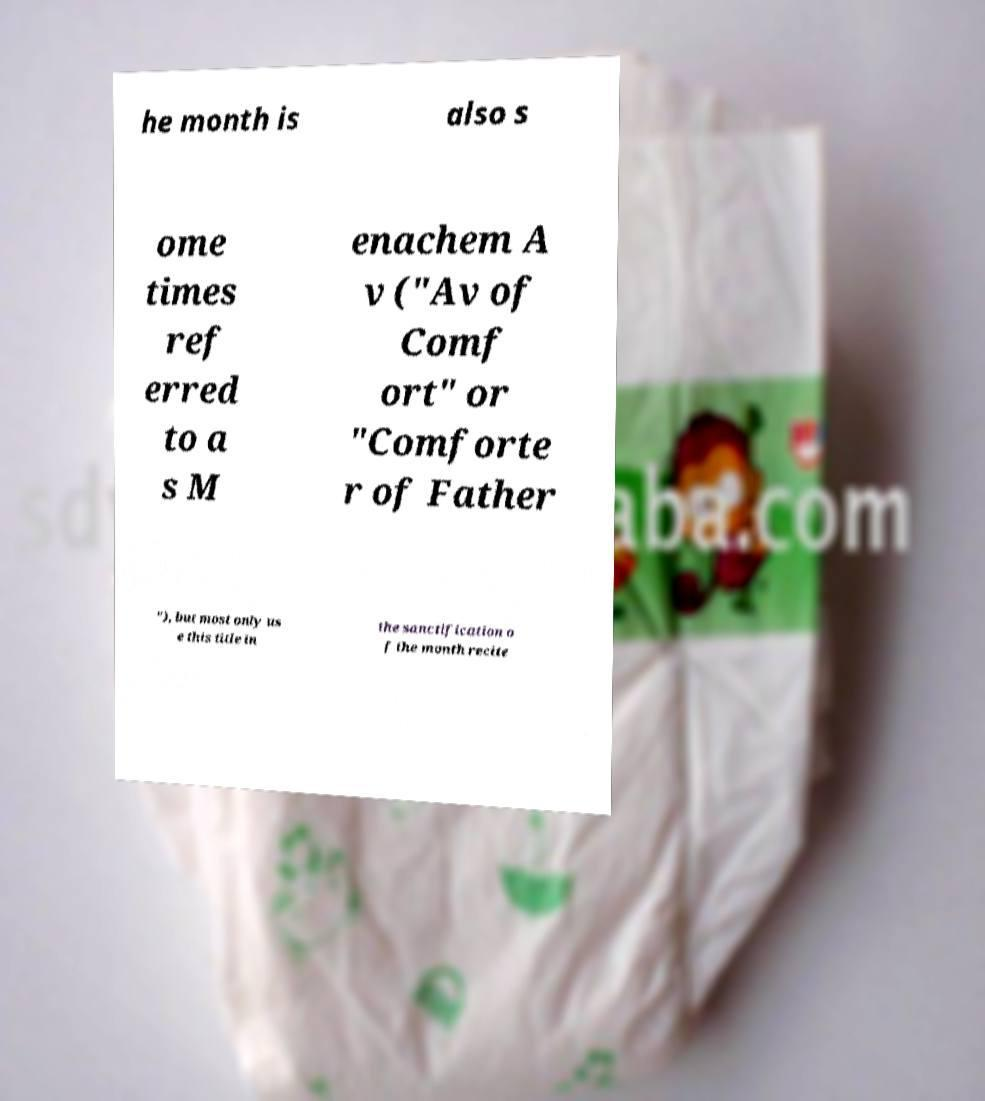For documentation purposes, I need the text within this image transcribed. Could you provide that? he month is also s ome times ref erred to a s M enachem A v ("Av of Comf ort" or "Comforte r of Father "), but most only us e this title in the sanctification o f the month recite 